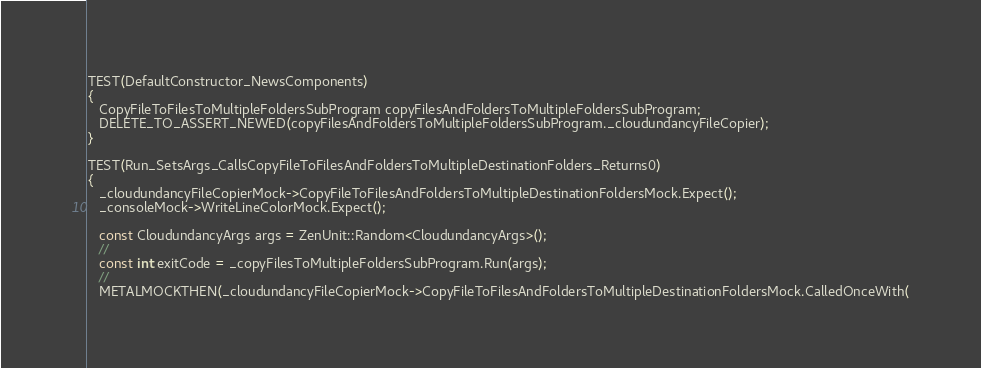<code> <loc_0><loc_0><loc_500><loc_500><_C++_>
TEST(DefaultConstructor_NewsComponents)
{
   CopyFileToFilesToMultipleFoldersSubProgram copyFilesAndFoldersToMultipleFoldersSubProgram;
   DELETE_TO_ASSERT_NEWED(copyFilesAndFoldersToMultipleFoldersSubProgram._cloudundancyFileCopier);
}

TEST(Run_SetsArgs_CallsCopyFileToFilesAndFoldersToMultipleDestinationFolders_Returns0)
{
   _cloudundancyFileCopierMock->CopyFileToFilesAndFoldersToMultipleDestinationFoldersMock.Expect();
   _consoleMock->WriteLineColorMock.Expect();

   const CloudundancyArgs args = ZenUnit::Random<CloudundancyArgs>();
   //
   const int exitCode = _copyFilesToMultipleFoldersSubProgram.Run(args);
   //
   METALMOCKTHEN(_cloudundancyFileCopierMock->CopyFileToFilesAndFoldersToMultipleDestinationFoldersMock.CalledOnceWith(</code> 